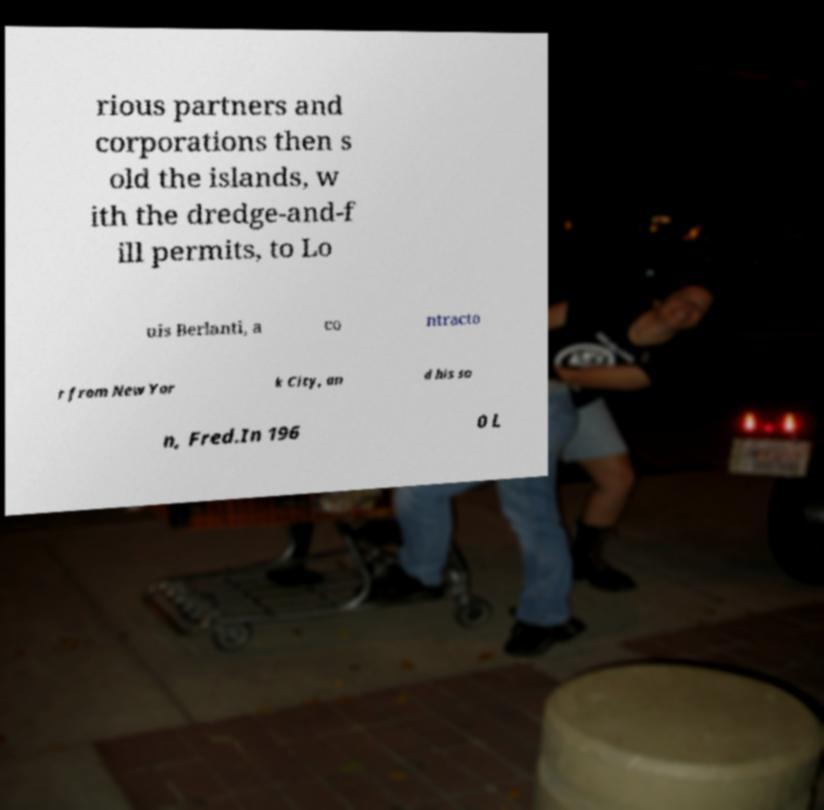Could you assist in decoding the text presented in this image and type it out clearly? rious partners and corporations then s old the islands, w ith the dredge-and-f ill permits, to Lo uis Berlanti, a co ntracto r from New Yor k City, an d his so n, Fred.In 196 0 L 